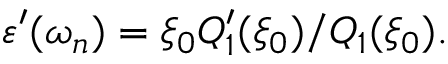Convert formula to latex. <formula><loc_0><loc_0><loc_500><loc_500>\varepsilon ^ { \prime } ( \omega _ { n } ) = \xi _ { 0 } Q _ { 1 } ^ { \prime } ( \xi _ { 0 } ) / Q _ { 1 } ( \xi _ { 0 } ) .</formula> 